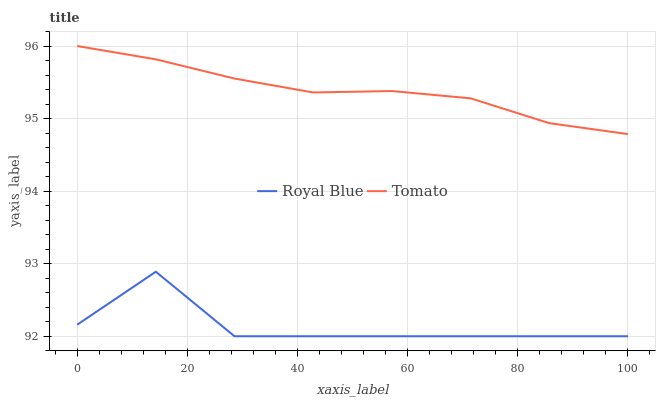Does Royal Blue have the minimum area under the curve?
Answer yes or no. Yes. Does Tomato have the maximum area under the curve?
Answer yes or no. Yes. Does Royal Blue have the maximum area under the curve?
Answer yes or no. No. Is Tomato the smoothest?
Answer yes or no. Yes. Is Royal Blue the roughest?
Answer yes or no. Yes. Is Royal Blue the smoothest?
Answer yes or no. No. Does Royal Blue have the lowest value?
Answer yes or no. Yes. Does Tomato have the highest value?
Answer yes or no. Yes. Does Royal Blue have the highest value?
Answer yes or no. No. Is Royal Blue less than Tomato?
Answer yes or no. Yes. Is Tomato greater than Royal Blue?
Answer yes or no. Yes. Does Royal Blue intersect Tomato?
Answer yes or no. No. 